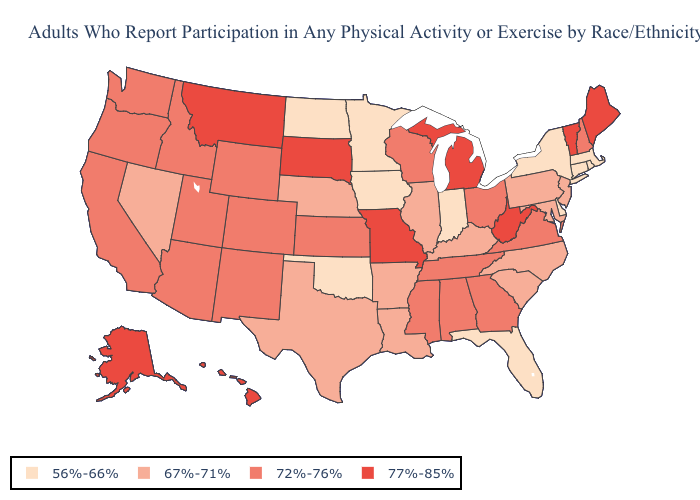Does Arizona have the lowest value in the USA?
Short answer required. No. Which states have the highest value in the USA?
Quick response, please. Alaska, Hawaii, Maine, Michigan, Missouri, Montana, South Dakota, Vermont, West Virginia. Which states have the highest value in the USA?
Quick response, please. Alaska, Hawaii, Maine, Michigan, Missouri, Montana, South Dakota, Vermont, West Virginia. Name the states that have a value in the range 56%-66%?
Answer briefly. Connecticut, Delaware, Florida, Indiana, Iowa, Massachusetts, Minnesota, New York, North Dakota, Oklahoma, Rhode Island. What is the lowest value in the Northeast?
Concise answer only. 56%-66%. Does Missouri have a higher value than North Carolina?
Be succinct. Yes. Among the states that border Virginia , does Tennessee have the lowest value?
Give a very brief answer. No. What is the lowest value in states that border Indiana?
Quick response, please. 67%-71%. Does Pennsylvania have the highest value in the USA?
Short answer required. No. Does Minnesota have the lowest value in the MidWest?
Give a very brief answer. Yes. Does Georgia have a higher value than Wyoming?
Short answer required. No. Is the legend a continuous bar?
Write a very short answer. No. Name the states that have a value in the range 77%-85%?
Answer briefly. Alaska, Hawaii, Maine, Michigan, Missouri, Montana, South Dakota, Vermont, West Virginia. How many symbols are there in the legend?
Concise answer only. 4. Name the states that have a value in the range 72%-76%?
Be succinct. Alabama, Arizona, California, Colorado, Georgia, Idaho, Kansas, Mississippi, New Hampshire, New Mexico, Ohio, Oregon, Tennessee, Utah, Virginia, Washington, Wisconsin, Wyoming. 